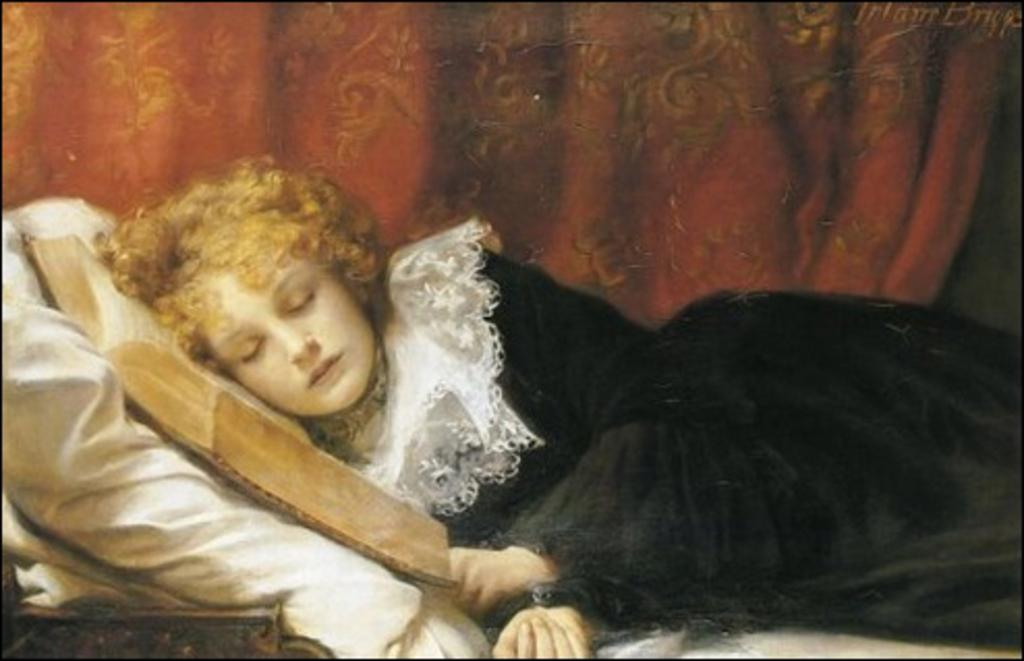What is the person in the image doing? There is a person lying on the bed in the image. What object is also present on the bed? There is a book on the bed. What can be seen in the background of the image? There is a curtain in the background of the image. How many quince are on the bed in the image? There are no quince present in the image. Are there any rabbits visible in the image? There are no rabbits present in the image. 